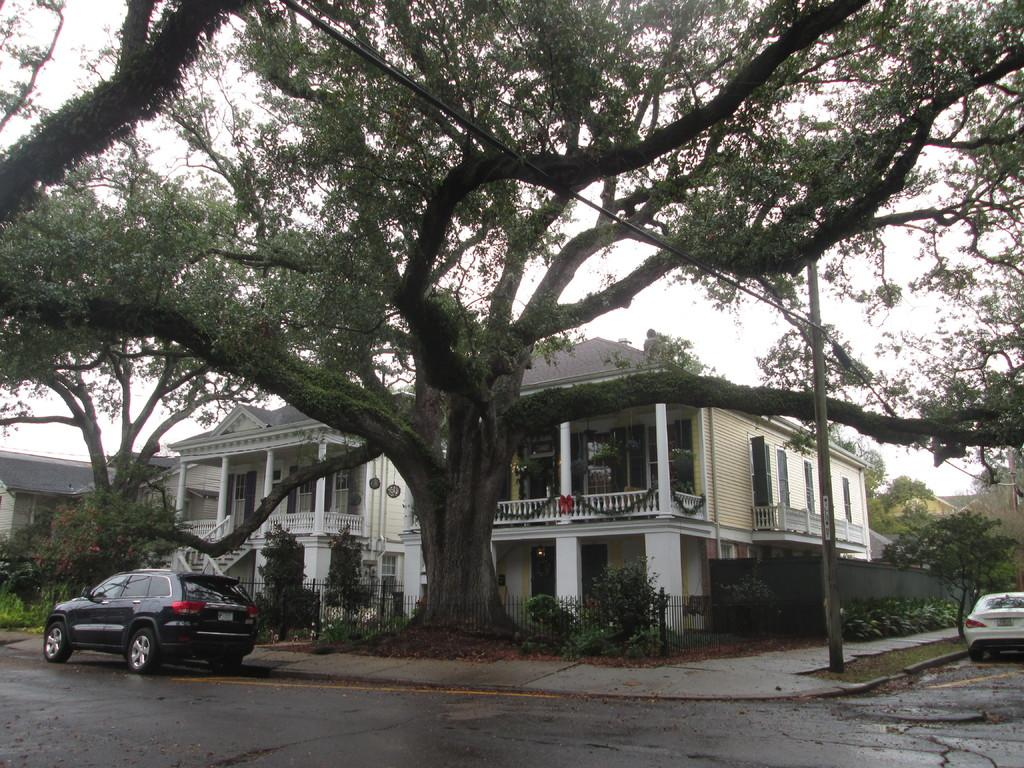What type of structures can be seen in the image? There are buildings in the image. What architectural features are present in the buildings? There are windows and stairs visible in the image. What type of vegetation is present in the image? There are trees in the image. What type of transportation can be seen in the image? There are vehicles in the image. What type of barrier is present in the image? There is fencing in the image. What type of vertical structure is present in the image? There is a pole in the image. What is the color of the sky in the image? The sky is white in color. How many brothers are depicted in the image? There are no people, let alone brothers, present in the image. What type of fabric is draped over the pole in the image? There is no fabric, let alone linen, present in the image. 